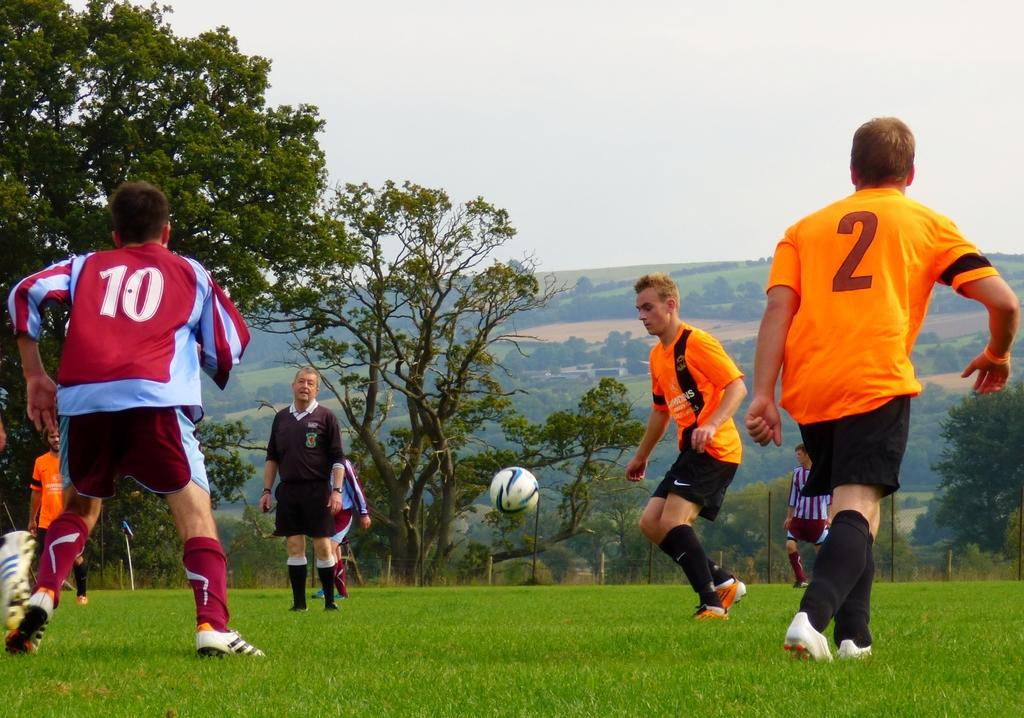What are the people in the image doing? There is a group of people on the ground in the image, which suggests they might be playing a game or engaging in some activity. What is happening with the ball in the image? A ball is in the air in the image, which could indicate that it is being thrown or kicked. What can be seen in the background of the image? There are trees and the sky visible in the background of the image. What type of dress is the fire wearing in the image? There is no fire or dress present in the image. How does the behavior of the people in the image change after the fire appears? There is no fire present in the image, so the behavior of the people does not change. 